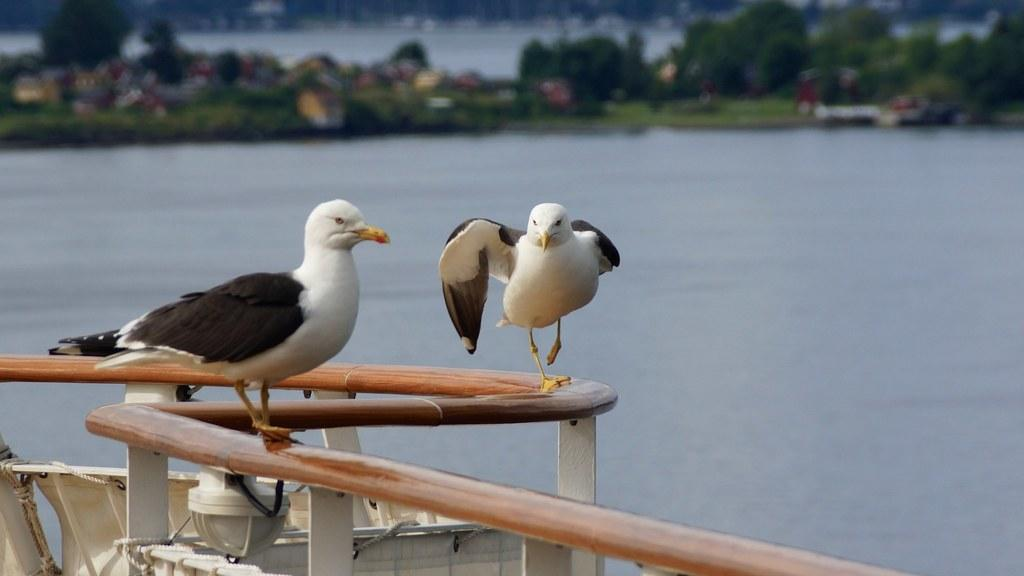What is the primary element visible in the image? There is water in the image. How many birds can be seen in the image? There are two birds in the image. What can be seen in the background of the image? There are trees in the background of the image. What type of light is being used to illuminate the pancake in the image? There is no pancake present in the image, so the question about light and a pancake cannot be answered. 